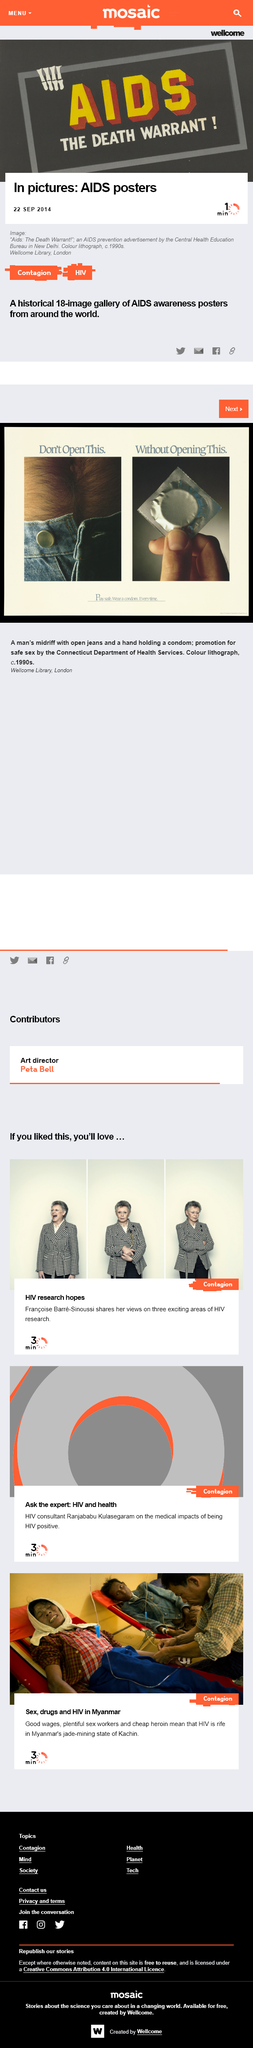Indicate a few pertinent items in this graphic. HIV is the main topic of all the articles listed above. Kachin is the jade-mining state of Myanmar. The main contributors that are making HIV rife in Myanmar include good wages, plentiful sex workers, and cheap heroin, which are the main reasons for the increased prevalence of HIV in the country. 